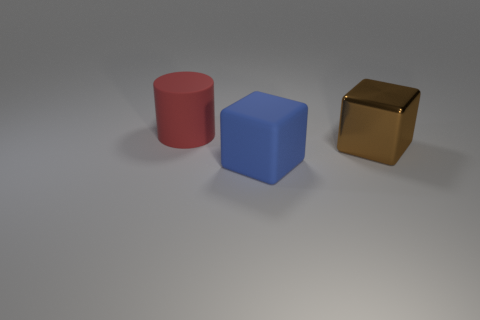Add 3 rubber cylinders. How many objects exist? 6 Subtract all cylinders. How many objects are left? 2 Subtract all brown cubes. How many cubes are left? 1 Subtract 1 brown cubes. How many objects are left? 2 Subtract all green cubes. Subtract all gray balls. How many cubes are left? 2 Subtract all red matte cubes. Subtract all brown metallic objects. How many objects are left? 2 Add 1 large red objects. How many large red objects are left? 2 Add 2 large blue rubber blocks. How many large blue rubber blocks exist? 3 